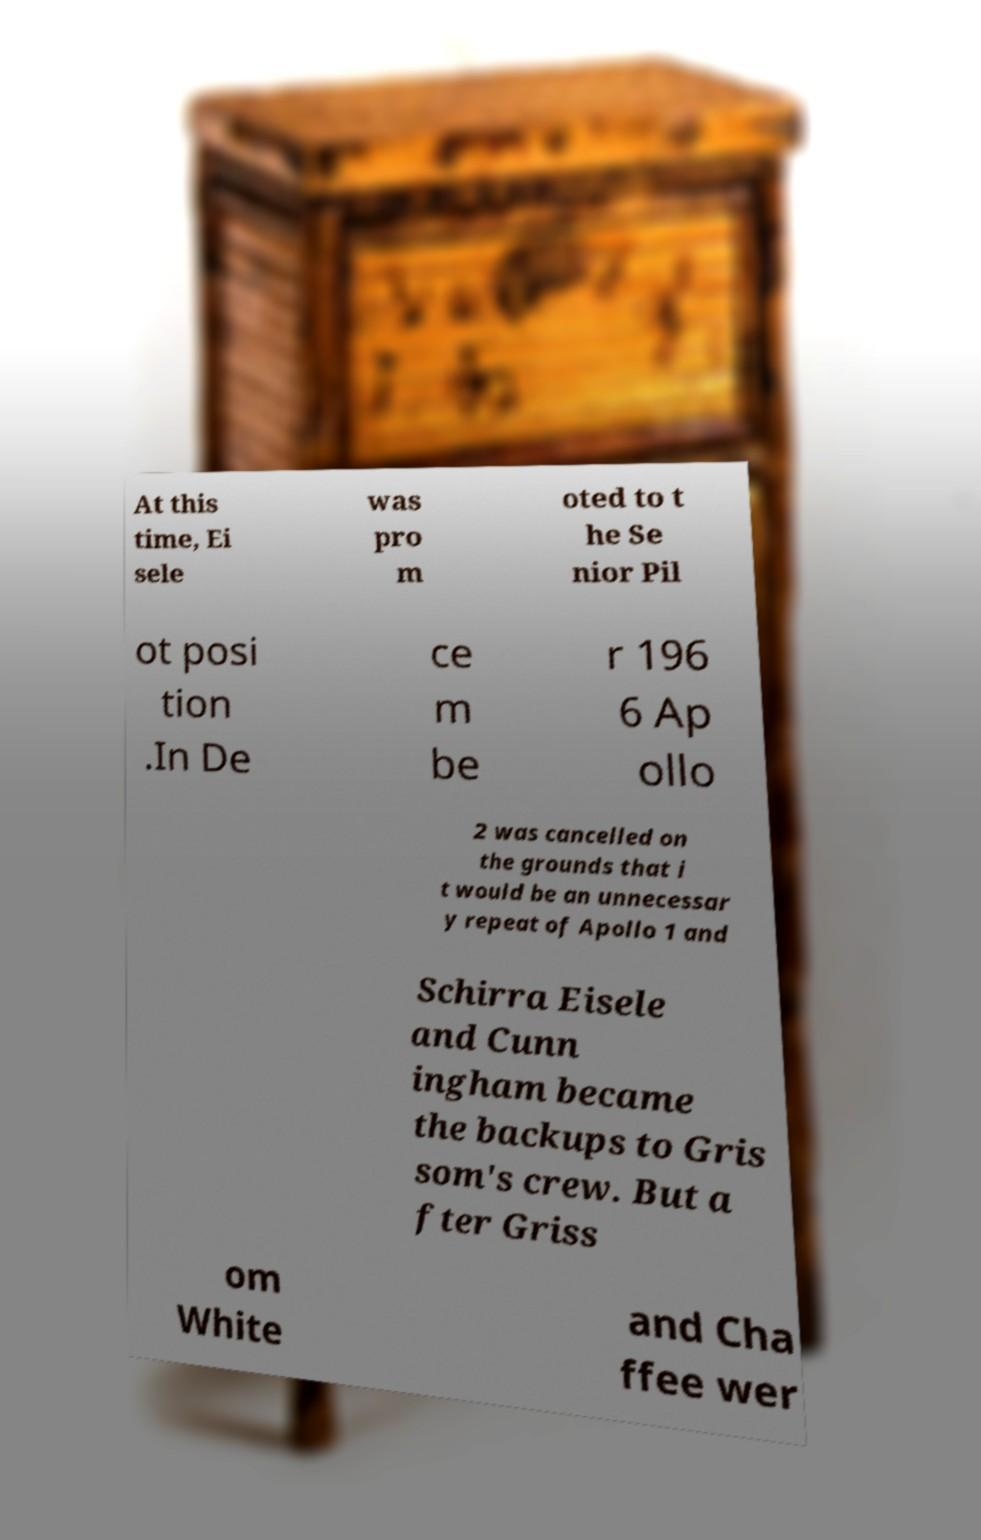Please read and relay the text visible in this image. What does it say? At this time, Ei sele was pro m oted to t he Se nior Pil ot posi tion .In De ce m be r 196 6 Ap ollo 2 was cancelled on the grounds that i t would be an unnecessar y repeat of Apollo 1 and Schirra Eisele and Cunn ingham became the backups to Gris som's crew. But a fter Griss om White and Cha ffee wer 